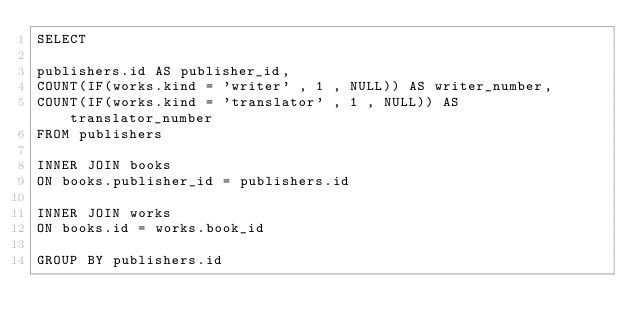Convert code to text. <code><loc_0><loc_0><loc_500><loc_500><_SQL_>SELECT 

publishers.id AS publisher_id,
COUNT(IF(works.kind = 'writer' , 1 , NULL)) AS writer_number,
COUNT(IF(works.kind = 'translator' , 1 , NULL)) AS translator_number
FROM publishers

INNER JOIN books
ON books.publisher_id = publishers.id

INNER JOIN works
ON books.id = works.book_id

GROUP BY publishers.id
</code> 